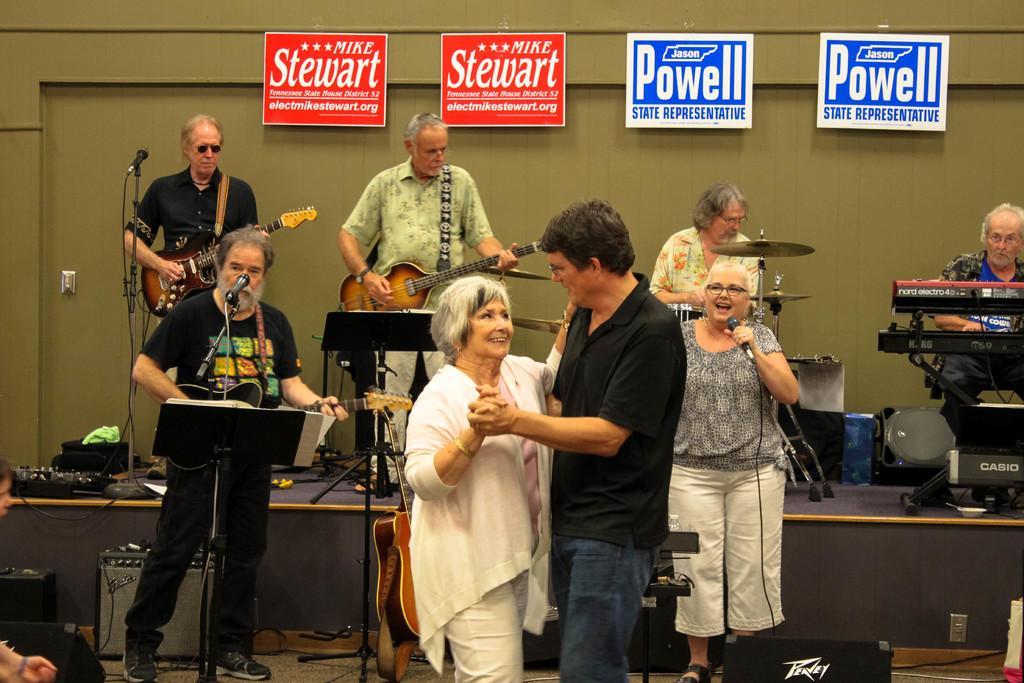Describe this image in one or two sentences. In the center of the image we can see a man and a woman standing holding each other. We can also see a person holding a guitar standing beside a speaker stand with a book on it and a woman holding a mic. We can also see some speaker boxes and wires on the floor. On the backside we can see a group of people playing musical instruments on the stage. We can also see speaker boxes, a cloth, wires and some boards with text on it hanged to a wall. 